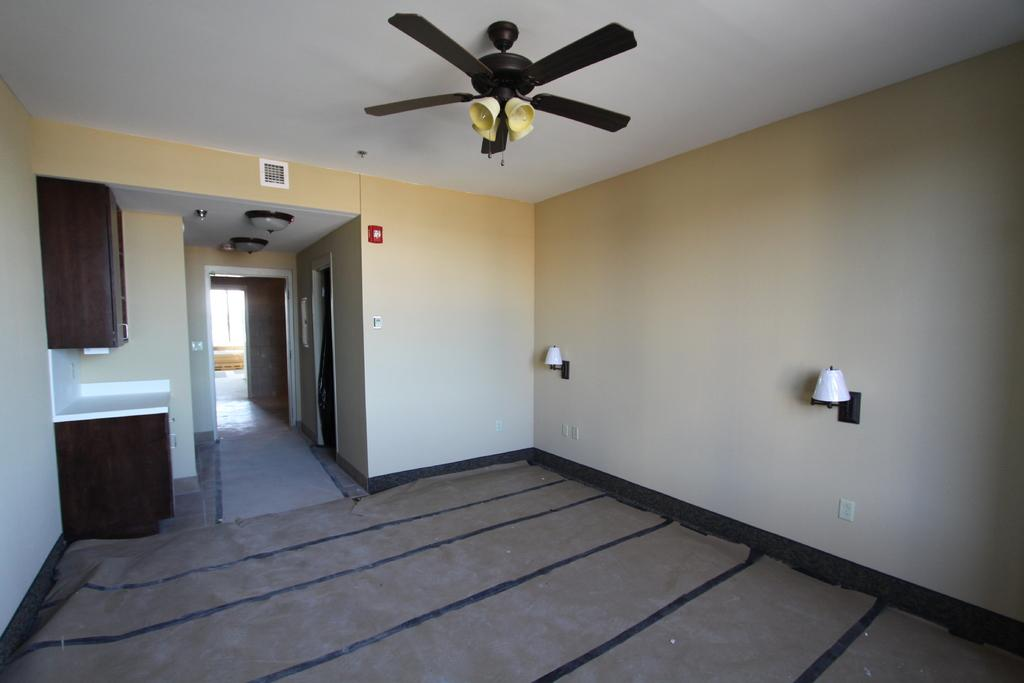What part of a building can be seen in the image? The image shows the inner part of a building. What can be seen illuminating the space in the image? There are lights visible in the image. What type of furniture is present in the image? A cupboard and a table are visible in the image. What structural elements are present in the image? The image includes walls. What other objects can be seen in the image? There are various objects in the image. What type of fan is visible at the top of the image? A light ceiling fan is visible at the top of the image. What type of salt can be seen on the table in the image? There is no salt present on the table in the image. Is there a baseball game happening in the image? There is no baseball game or any reference to sports in the image. 